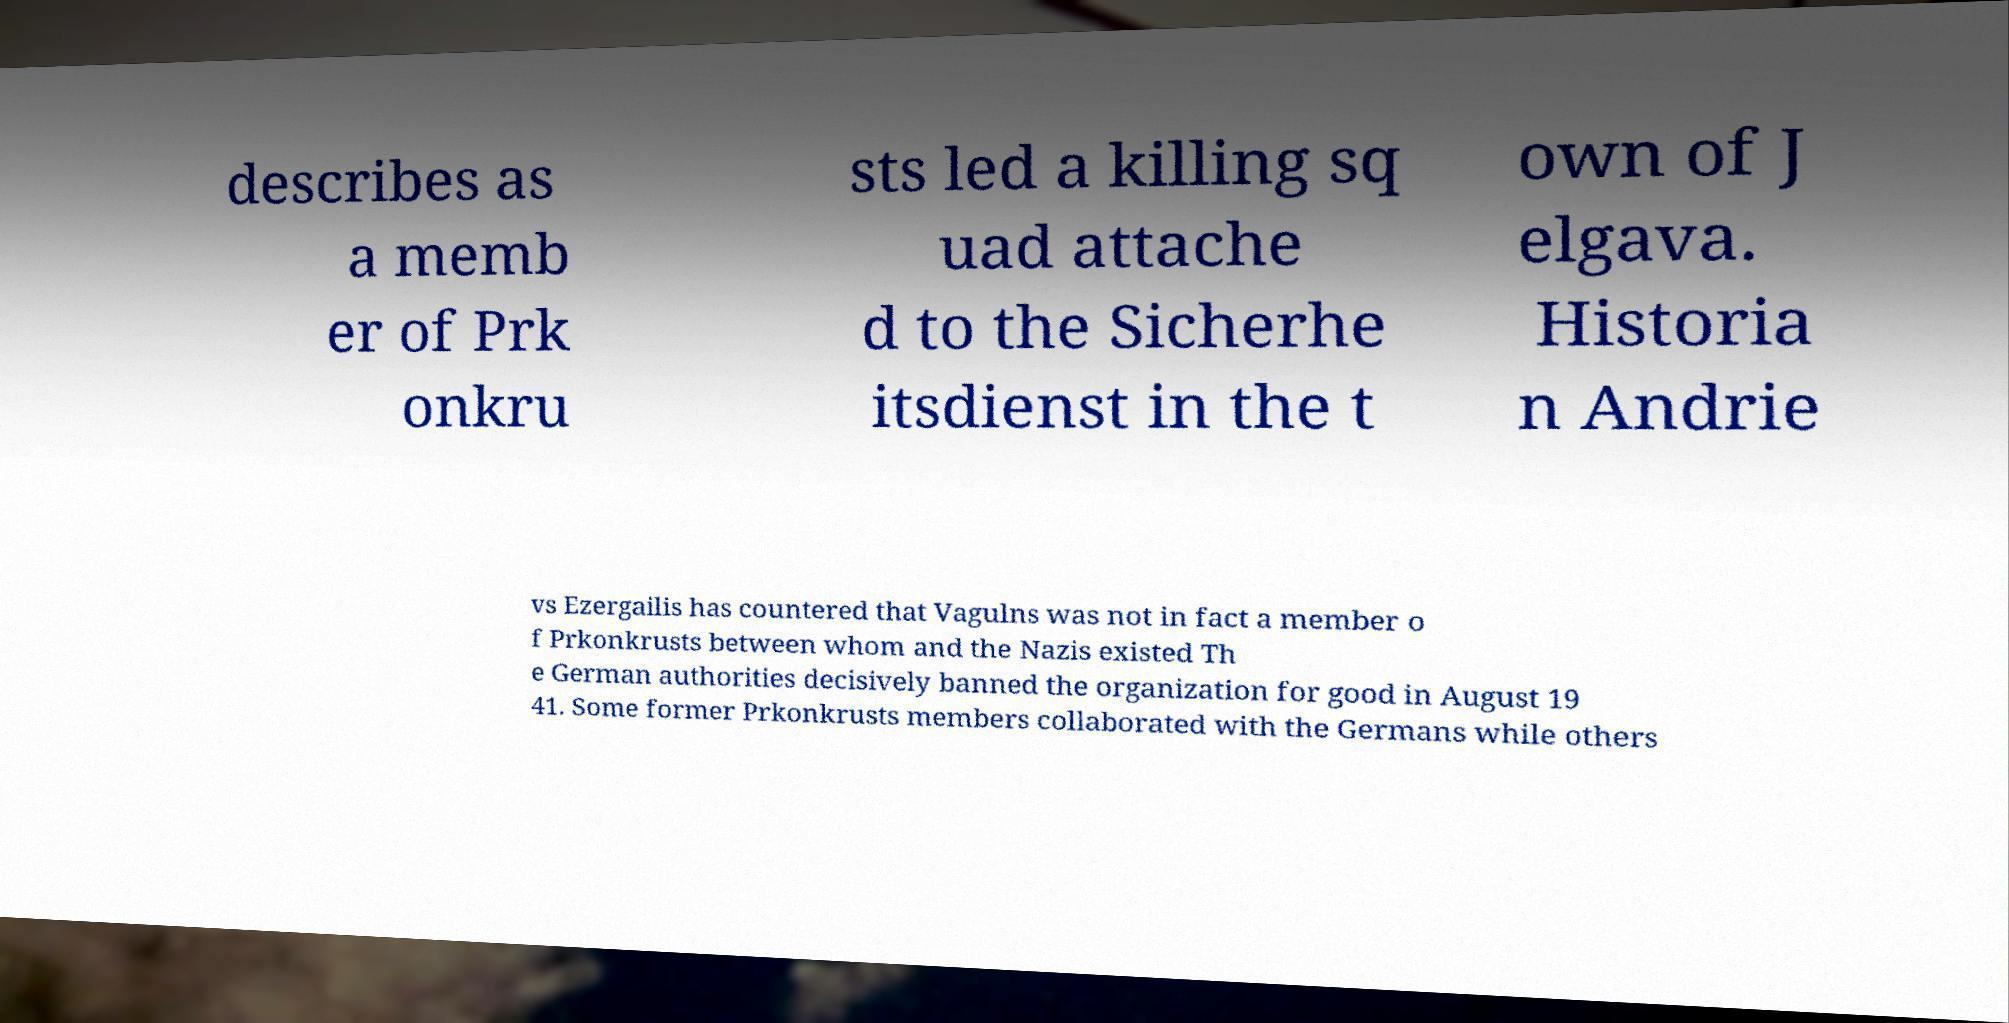For documentation purposes, I need the text within this image transcribed. Could you provide that? describes as a memb er of Prk onkru sts led a killing sq uad attache d to the Sicherhe itsdienst in the t own of J elgava. Historia n Andrie vs Ezergailis has countered that Vagulns was not in fact a member o f Prkonkrusts between whom and the Nazis existed Th e German authorities decisively banned the organization for good in August 19 41. Some former Prkonkrusts members collaborated with the Germans while others 